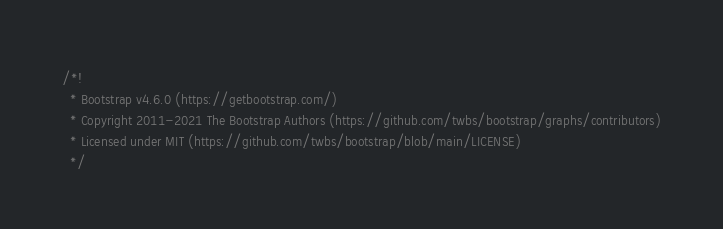Convert code to text. <code><loc_0><loc_0><loc_500><loc_500><_JavaScript_>/*!
  * Bootstrap v4.6.0 (https://getbootstrap.com/)
  * Copyright 2011-2021 The Bootstrap Authors (https://github.com/twbs/bootstrap/graphs/contributors)
  * Licensed under MIT (https://github.com/twbs/bootstrap/blob/main/LICENSE)
  */</code> 